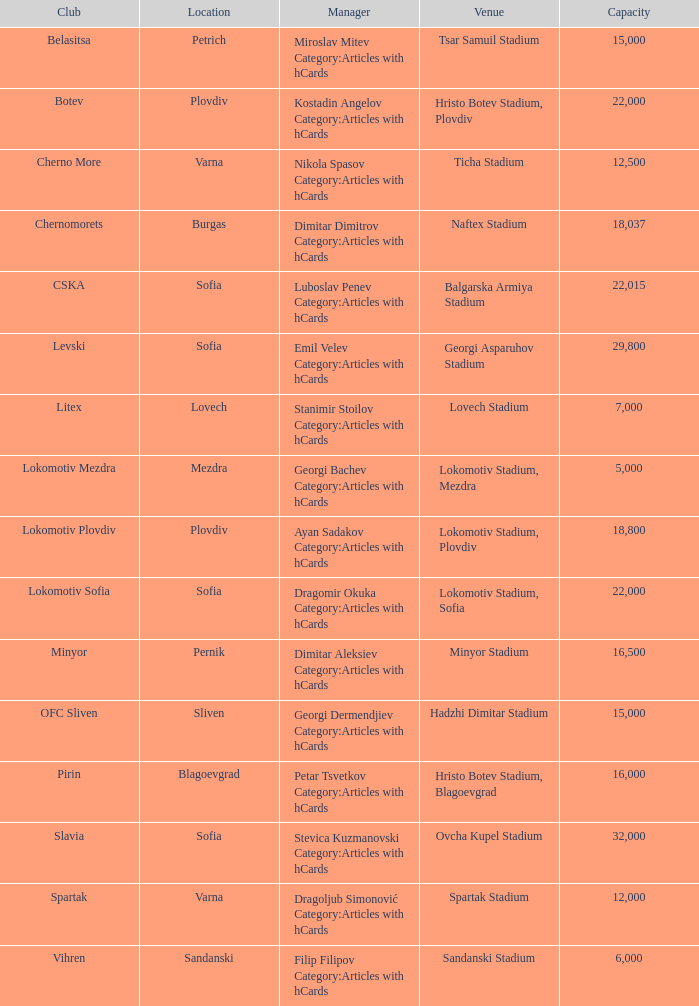What is the largest capacity for the venue, ticha stadium, found in varna? 12500.0. 